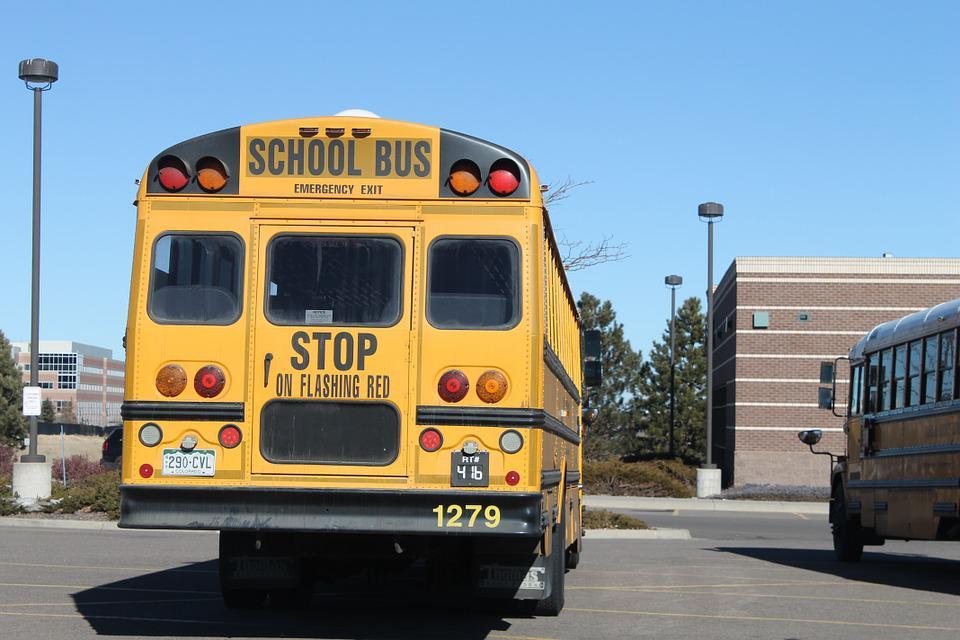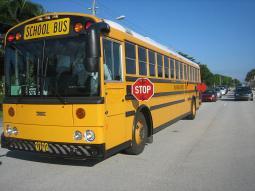The first image is the image on the left, the second image is the image on the right. Considering the images on both sides, is "The right image shows a flat-fronted bus angled facing forward." valid? Answer yes or no. Yes. The first image is the image on the left, the second image is the image on the right. Assess this claim about the two images: "In at least one image there is an emergency exit in the back of the bus face forward with the front of the bus not visible.". Correct or not? Answer yes or no. Yes. 